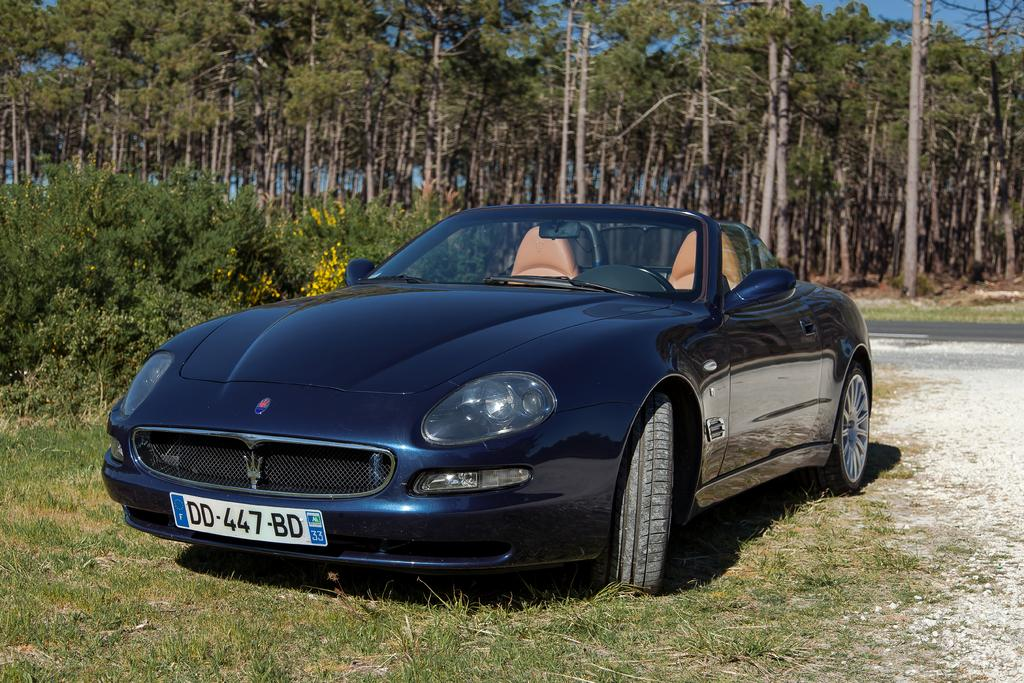What is the main subject of the image? The main subject of the image is a car. Where is the car located in the image? The car is on the grass. What can be seen in the background of the image? There are trees in the background of the image. Is there any indication of a path or route in the image? Yes, there is a road visible in the image. What type of tub is visible in the image? There is no tub present in the image. How many people are in the group that is walking on the road in the image? There is no group of people walking on the road in the image; it only features a car on the grass. 